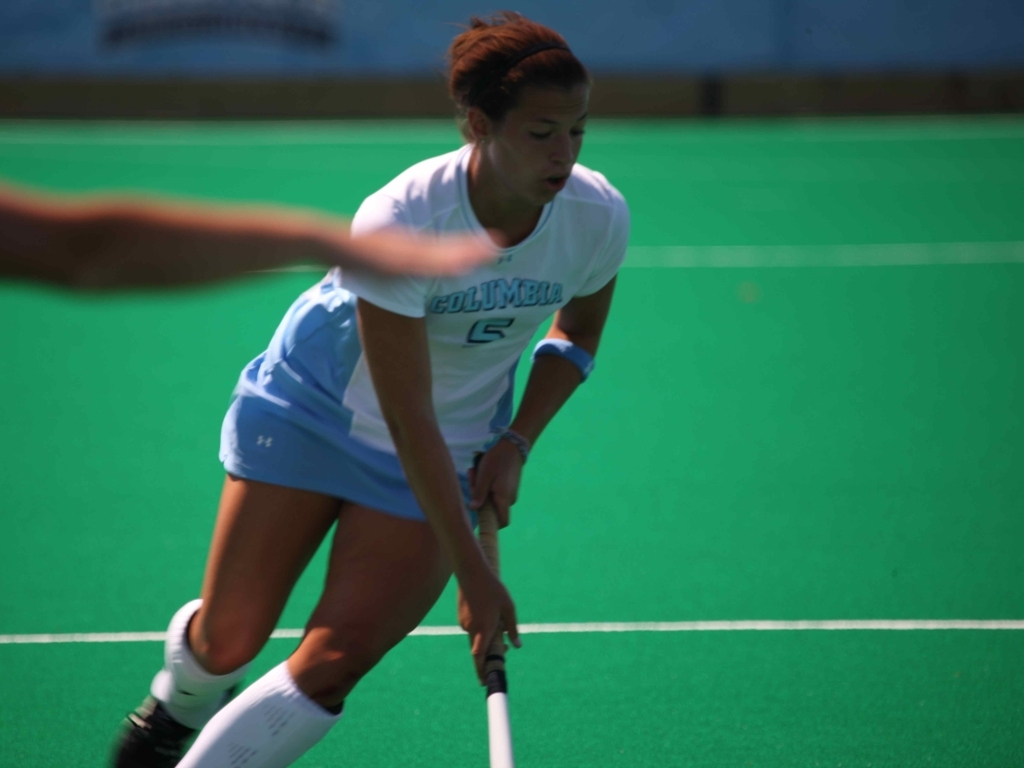Can you describe the player's action? The player appears to be in the process of dribbling or controlling the hockey ball, a typical movement in field hockey. She is leaning forward slightly, focusing intently on the ball, indicating an active play situation. 